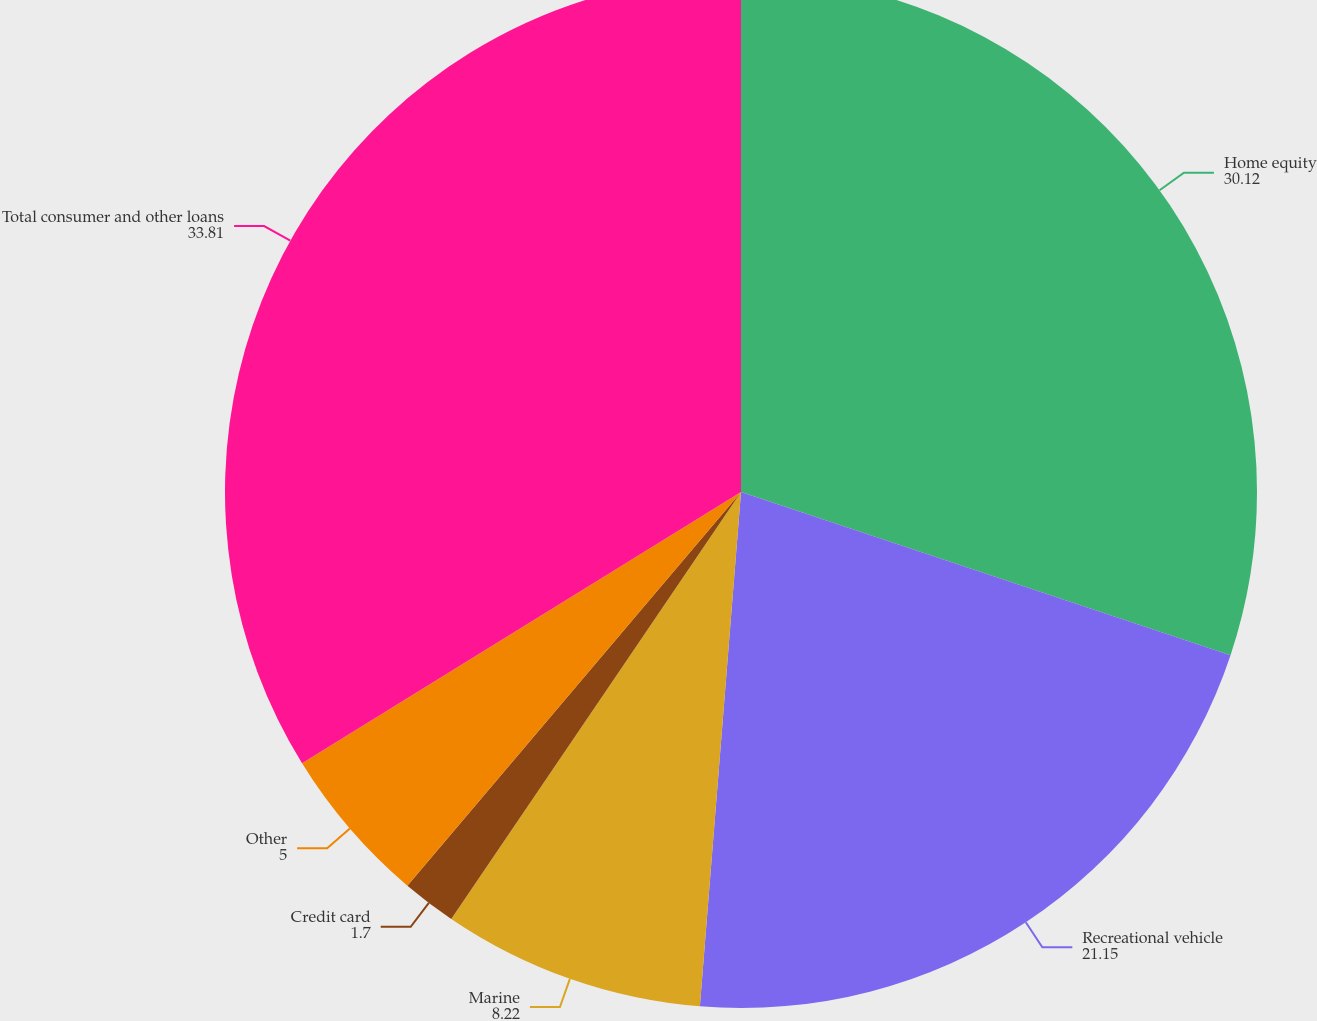Convert chart. <chart><loc_0><loc_0><loc_500><loc_500><pie_chart><fcel>Home equity<fcel>Recreational vehicle<fcel>Marine<fcel>Credit card<fcel>Other<fcel>Total consumer and other loans<nl><fcel>30.12%<fcel>21.15%<fcel>8.22%<fcel>1.7%<fcel>5.0%<fcel>33.81%<nl></chart> 